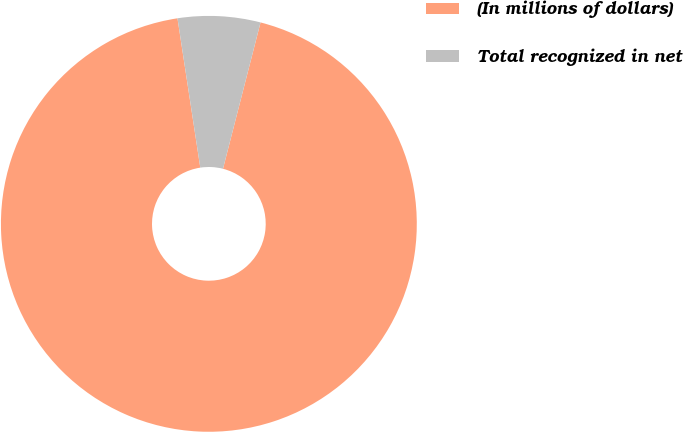Convert chart. <chart><loc_0><loc_0><loc_500><loc_500><pie_chart><fcel>(In millions of dollars)<fcel>Total recognized in net<nl><fcel>93.59%<fcel>6.41%<nl></chart> 